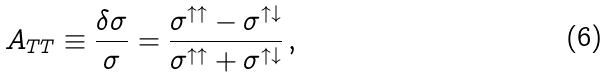<formula> <loc_0><loc_0><loc_500><loc_500>A _ { T T } \equiv \frac { \delta { \sigma } } { \sigma } = \frac { \sigma ^ { \uparrow \uparrow } - \sigma ^ { \uparrow \downarrow } } { \sigma ^ { \uparrow \uparrow } + \sigma ^ { \uparrow \downarrow } } \, ,</formula> 